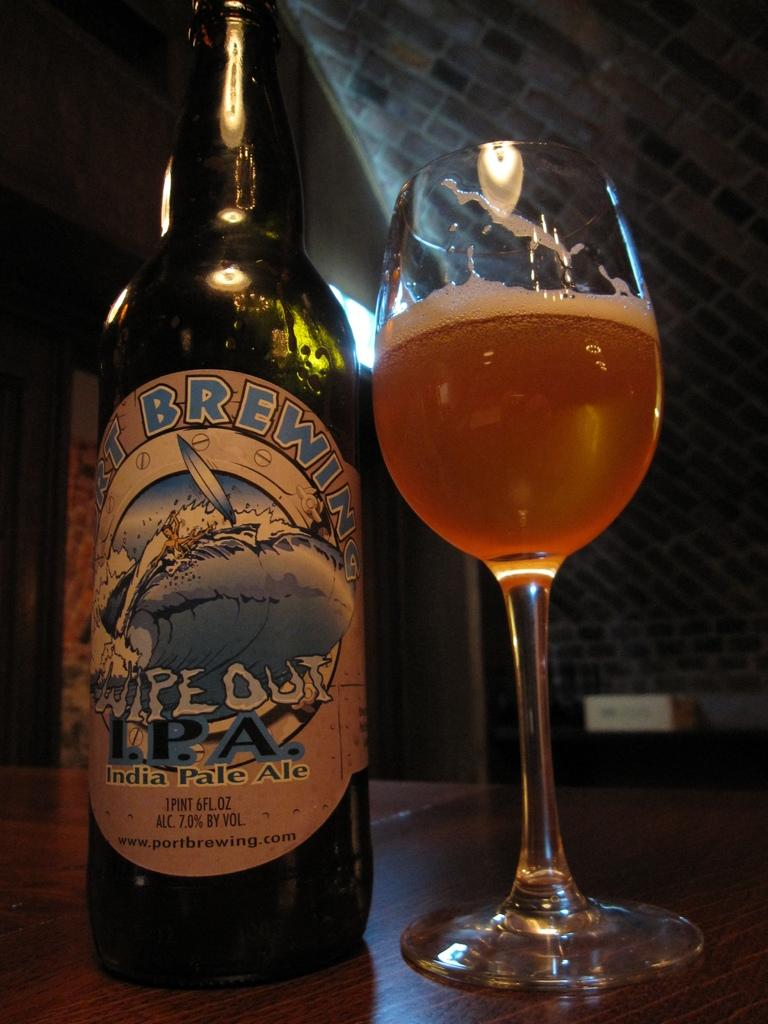<image>
Give a short and clear explanation of the subsequent image. One pint of India Pale Ale sitting on a table. 